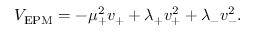<formula> <loc_0><loc_0><loc_500><loc_500>V _ { E P M } = - \mu _ { + } ^ { 2 } v _ { + } + \lambda _ { + } v _ { + } ^ { 2 } + \lambda _ { - } v _ { - } ^ { 2 } .</formula> 